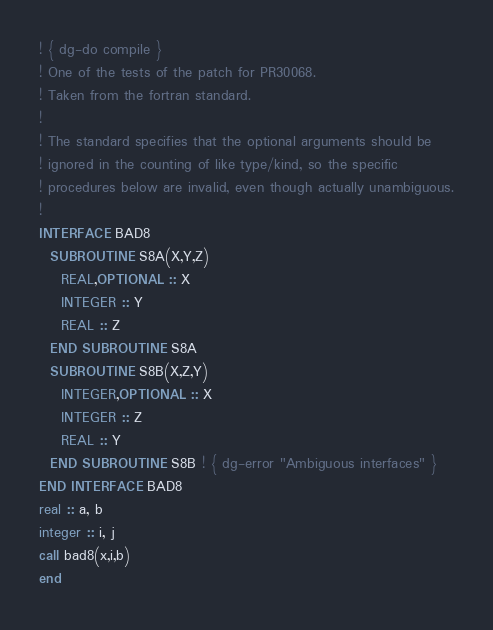<code> <loc_0><loc_0><loc_500><loc_500><_FORTRAN_>! { dg-do compile }
! One of the tests of the patch for PR30068.
! Taken from the fortran standard.
!
! The standard specifies that the optional arguments should be
! ignored in the counting of like type/kind, so the specific
! procedures below are invalid, even though actually unambiguous.
!
INTERFACE BAD8
  SUBROUTINE S8A(X,Y,Z)
    REAL,OPTIONAL :: X
    INTEGER :: Y
    REAL :: Z
  END SUBROUTINE S8A
  SUBROUTINE S8B(X,Z,Y)
    INTEGER,OPTIONAL :: X
    INTEGER :: Z
    REAL :: Y
  END SUBROUTINE S8B ! { dg-error "Ambiguous interfaces" }
END INTERFACE BAD8
real :: a, b
integer :: i, j
call bad8(x,i,b)
end
</code> 